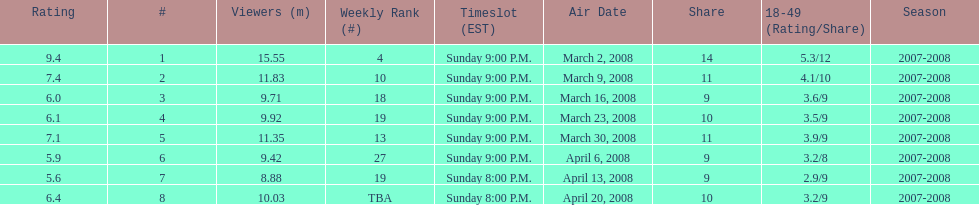How long did the program air for in days? 8. Help me parse the entirety of this table. {'header': ['Rating', '#', 'Viewers (m)', 'Weekly Rank (#)', 'Timeslot (EST)', 'Air Date', 'Share', '18-49 (Rating/Share)', 'Season'], 'rows': [['9.4', '1', '15.55', '4', 'Sunday 9:00 P.M.', 'March 2, 2008', '14', '5.3/12', '2007-2008'], ['7.4', '2', '11.83', '10', 'Sunday 9:00 P.M.', 'March 9, 2008', '11', '4.1/10', '2007-2008'], ['6.0', '3', '9.71', '18', 'Sunday 9:00 P.M.', 'March 16, 2008', '9', '3.6/9', '2007-2008'], ['6.1', '4', '9.92', '19', 'Sunday 9:00 P.M.', 'March 23, 2008', '10', '3.5/9', '2007-2008'], ['7.1', '5', '11.35', '13', 'Sunday 9:00 P.M.', 'March 30, 2008', '11', '3.9/9', '2007-2008'], ['5.9', '6', '9.42', '27', 'Sunday 9:00 P.M.', 'April 6, 2008', '9', '3.2/8', '2007-2008'], ['5.6', '7', '8.88', '19', 'Sunday 8:00 P.M.', 'April 13, 2008', '9', '2.9/9', '2007-2008'], ['6.4', '8', '10.03', 'TBA', 'Sunday 8:00 P.M.', 'April 20, 2008', '10', '3.2/9', '2007-2008']]} 